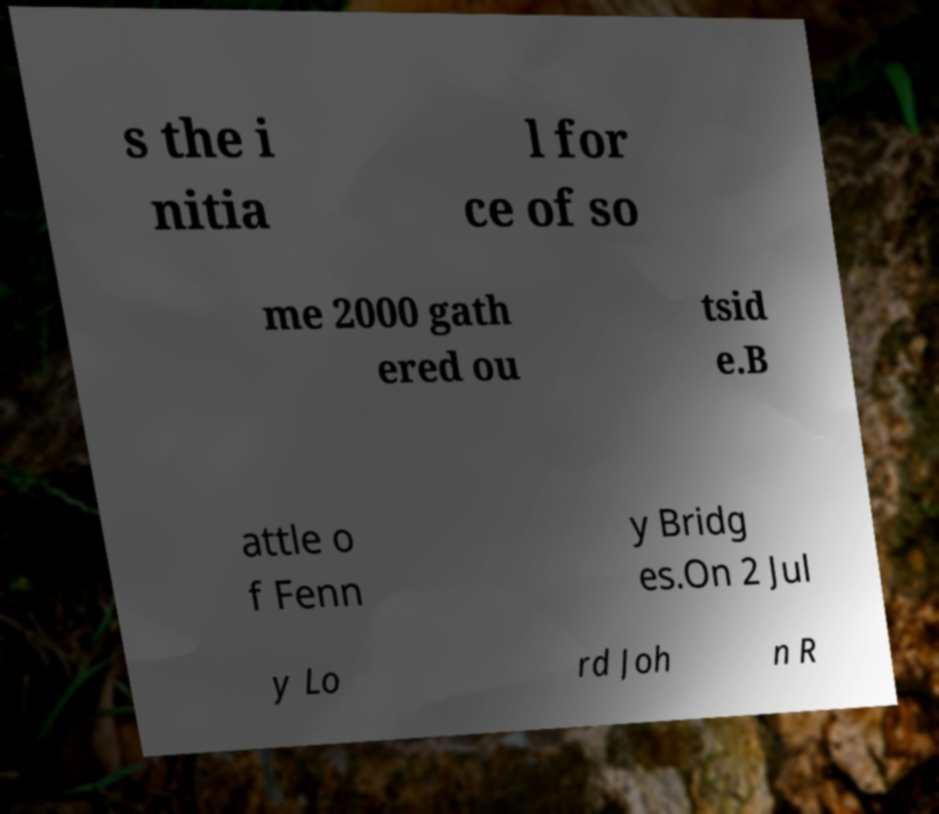I need the written content from this picture converted into text. Can you do that? s the i nitia l for ce of so me 2000 gath ered ou tsid e.B attle o f Fenn y Bridg es.On 2 Jul y Lo rd Joh n R 